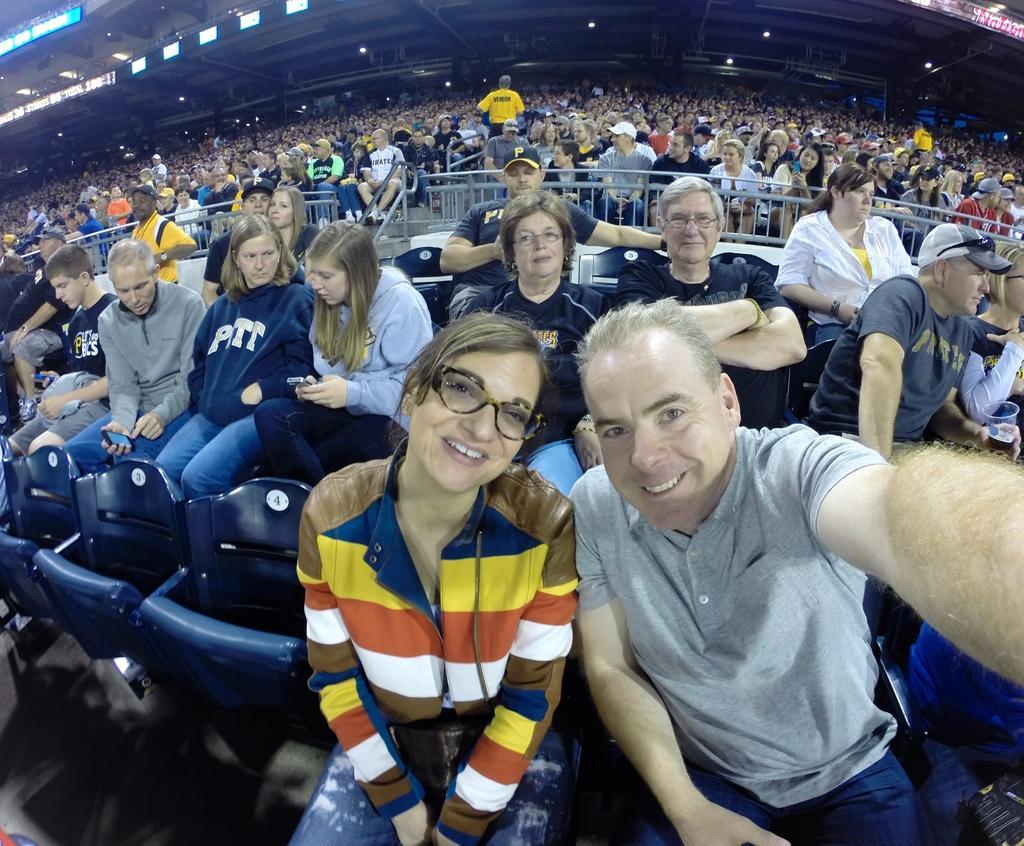Describe this image in one or two sentences. In this picture there are people and we can see stadium, chairs, lights, railings and boards. 